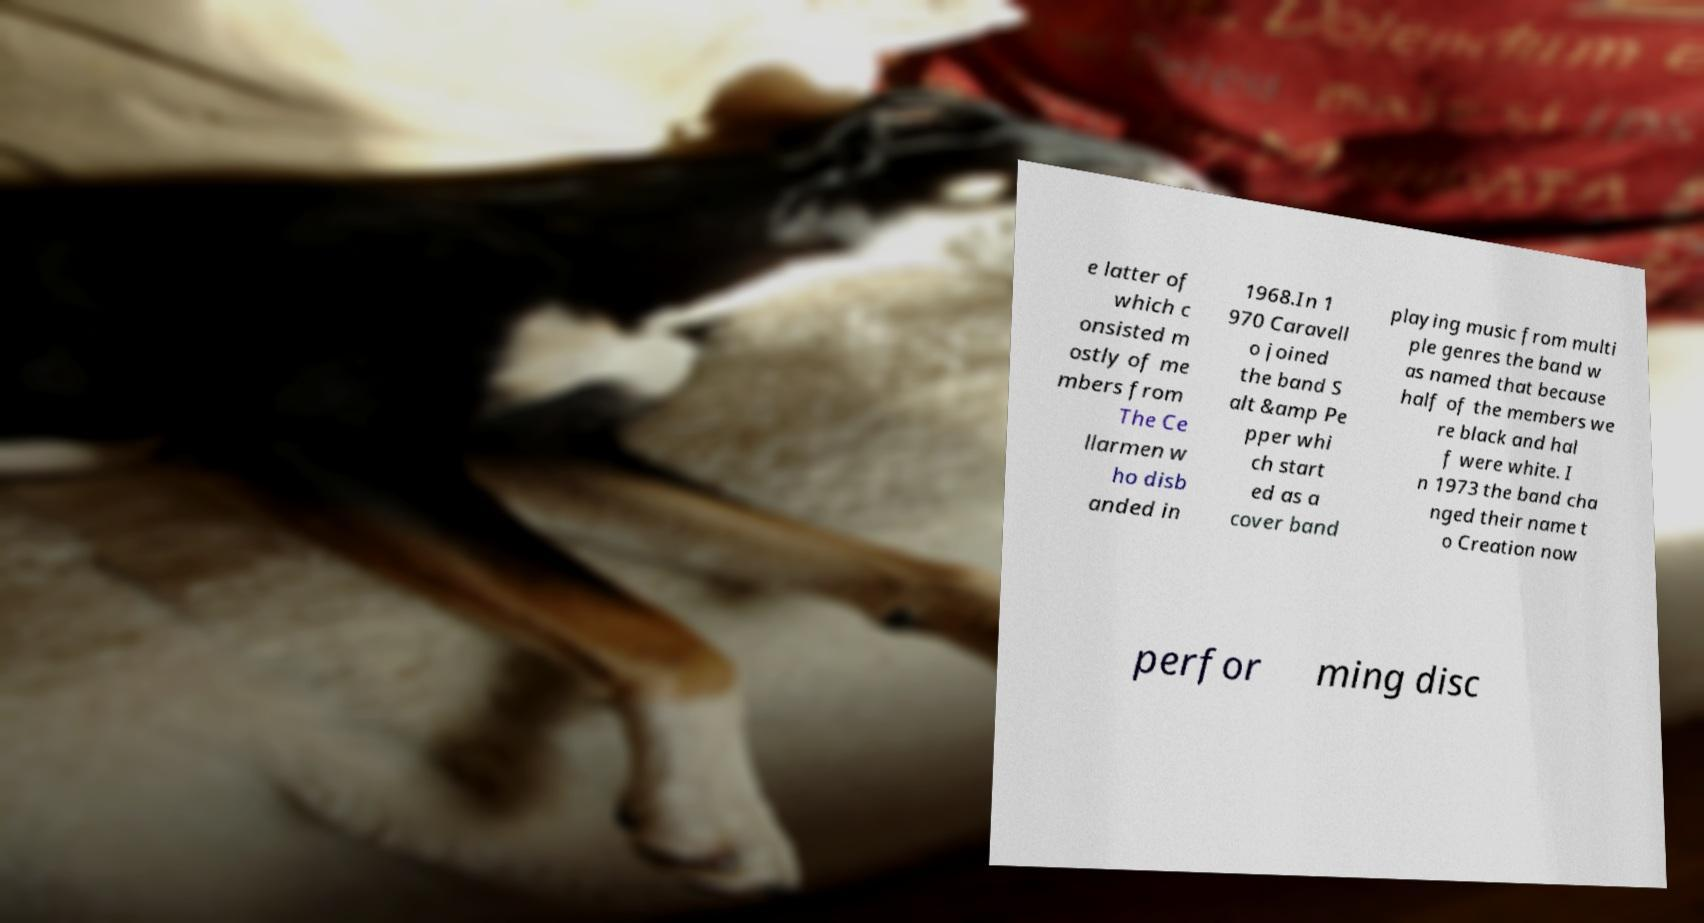Please read and relay the text visible in this image. What does it say? e latter of which c onsisted m ostly of me mbers from The Ce llarmen w ho disb anded in 1968.In 1 970 Caravell o joined the band S alt &amp Pe pper whi ch start ed as a cover band playing music from multi ple genres the band w as named that because half of the members we re black and hal f were white. I n 1973 the band cha nged their name t o Creation now perfor ming disc 